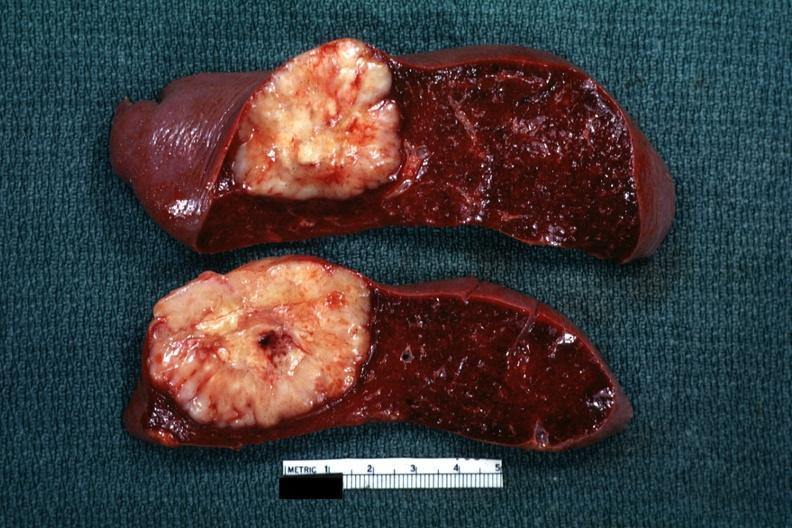was serous cyst reticulum cell sarcoma?
Answer the question using a single word or phrase. No 